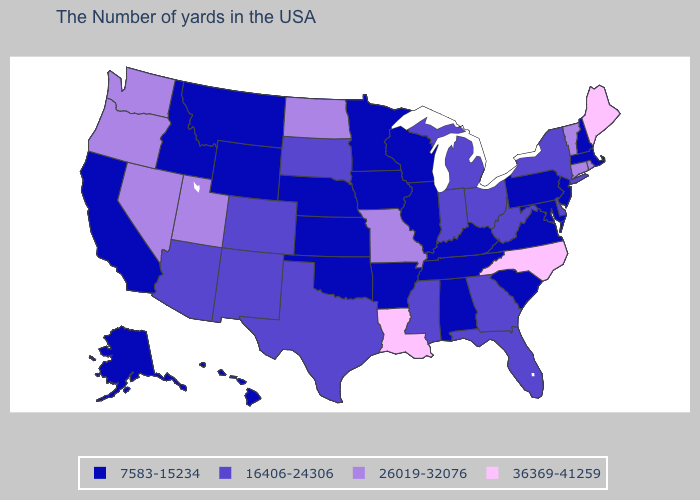How many symbols are there in the legend?
Short answer required. 4. What is the highest value in states that border Louisiana?
Concise answer only. 16406-24306. Which states have the lowest value in the USA?
Be succinct. Massachusetts, New Hampshire, New Jersey, Maryland, Pennsylvania, Virginia, South Carolina, Kentucky, Alabama, Tennessee, Wisconsin, Illinois, Arkansas, Minnesota, Iowa, Kansas, Nebraska, Oklahoma, Wyoming, Montana, Idaho, California, Alaska, Hawaii. What is the value of Pennsylvania?
Be succinct. 7583-15234. How many symbols are there in the legend?
Quick response, please. 4. What is the value of West Virginia?
Write a very short answer. 16406-24306. Name the states that have a value in the range 7583-15234?
Short answer required. Massachusetts, New Hampshire, New Jersey, Maryland, Pennsylvania, Virginia, South Carolina, Kentucky, Alabama, Tennessee, Wisconsin, Illinois, Arkansas, Minnesota, Iowa, Kansas, Nebraska, Oklahoma, Wyoming, Montana, Idaho, California, Alaska, Hawaii. How many symbols are there in the legend?
Write a very short answer. 4. What is the highest value in the MidWest ?
Concise answer only. 26019-32076. Name the states that have a value in the range 36369-41259?
Concise answer only. Maine, North Carolina, Louisiana. What is the highest value in the USA?
Write a very short answer. 36369-41259. Name the states that have a value in the range 16406-24306?
Be succinct. New York, Delaware, West Virginia, Ohio, Florida, Georgia, Michigan, Indiana, Mississippi, Texas, South Dakota, Colorado, New Mexico, Arizona. Name the states that have a value in the range 36369-41259?
Be succinct. Maine, North Carolina, Louisiana. Which states have the highest value in the USA?
Give a very brief answer. Maine, North Carolina, Louisiana. 